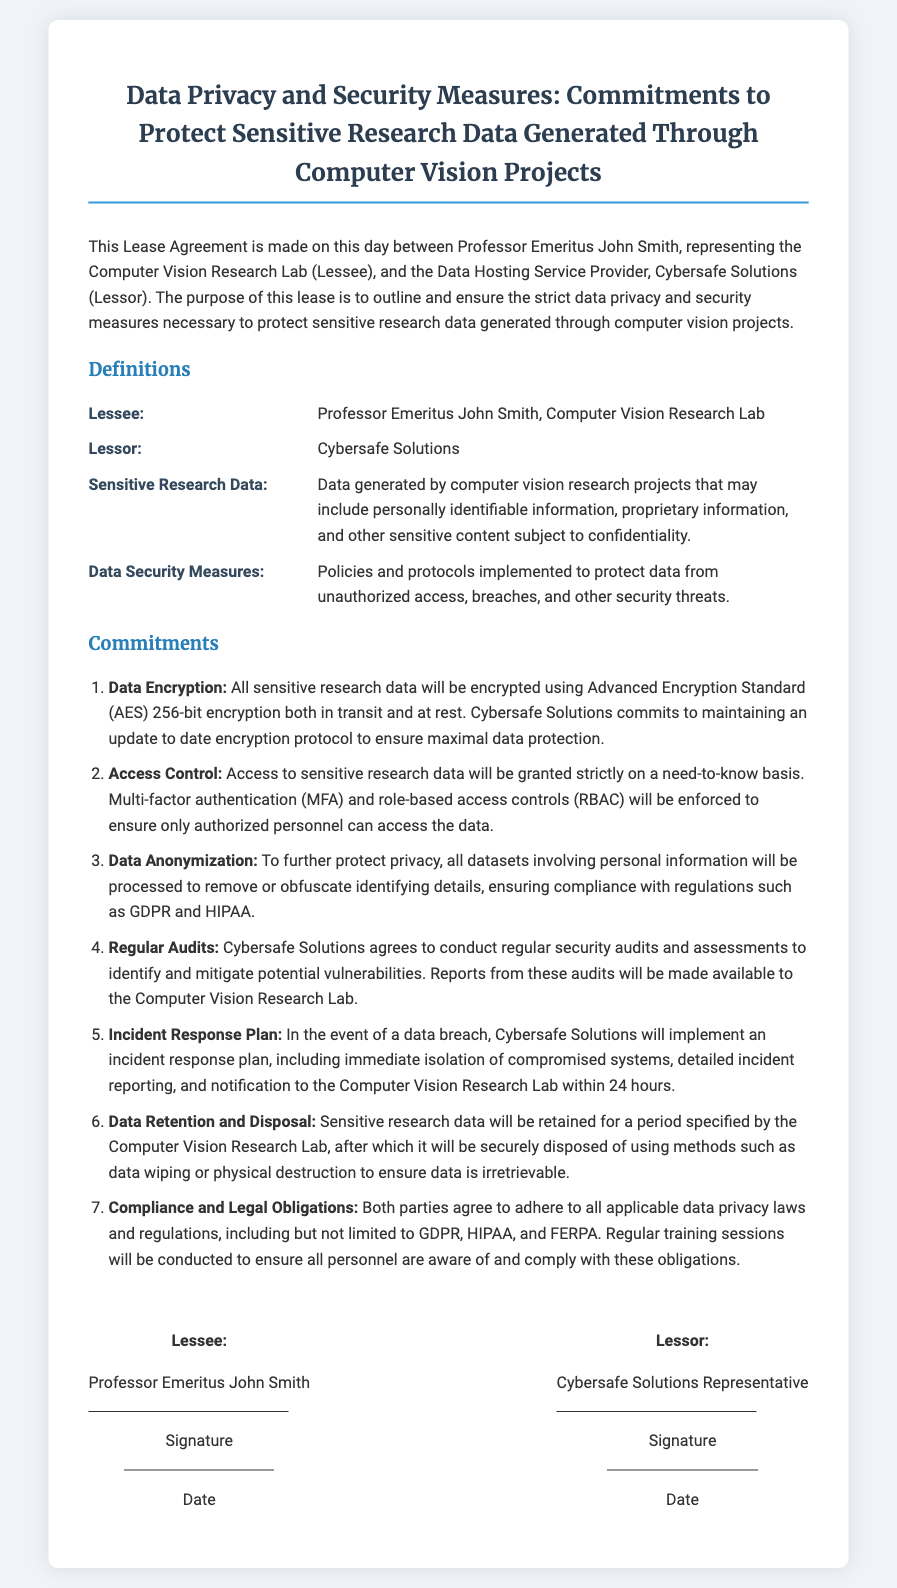What is the name of the lessee? The lessee is identified as Professor Emeritus John Smith, representing the Computer Vision Research Lab.
Answer: Professor Emeritus John Smith What type of encryption will be used? The document specifies that Advanced Encryption Standard (AES) 256-bit encryption will be used for data protection.
Answer: AES 256-bit Who is the lessor? The lessor is Cybersafe Solutions, the Data Hosting Service Provider mentioned in the lease agreement.
Answer: Cybersafe Solutions How long will sensitive research data be retained? The specific duration for data retention is to be specified by the Computer Vision Research Lab, indicated in the commitments.
Answer: Specified by the Computer Vision Research Lab What is the incident response plan's notification timeframe? The document states that notification to the Computer Vision Research Lab will occur within 24 hours in case of a data breach.
Answer: 24 hours What type of access control will be enforced? The access control measures specified in the document include multi-factor authentication (MFA) and role-based access controls (RBAC).
Answer: MFA and RBAC What does the term "Sensitive Research Data" refer to? Sensitive Research Data pertains to data generated by computer vision research projects that may include personally identifiable information and proprietary information.
Answer: Data generated by computer vision research projects What laws must both parties comply with? The lease agreement specifies compliance with GDPR, HIPAA, and FERPA among other applicable data privacy laws.
Answer: GDPR, HIPAA, FERPA How often will regular audits be conducted? The frequency of audits is not explicitly mentioned, but the agreement requires Cybersafe Solutions to conduct them regularly.
Answer: Regularly 